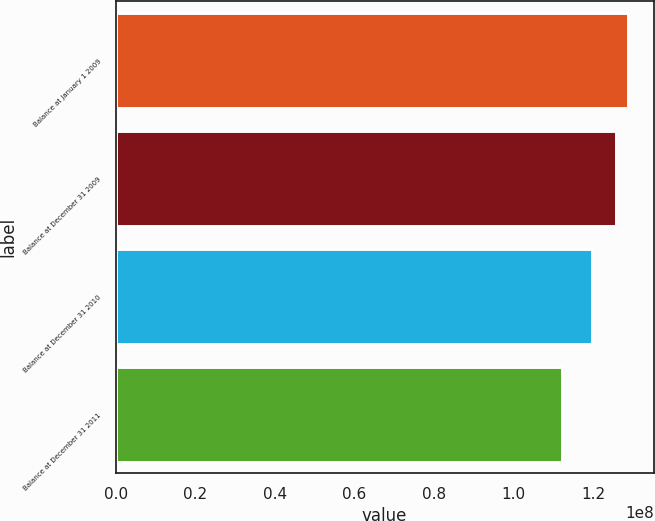Convert chart. <chart><loc_0><loc_0><loc_500><loc_500><bar_chart><fcel>Balance at January 1 2009<fcel>Balance at December 31 2009<fcel>Balance at December 31 2010<fcel>Balance at December 31 2011<nl><fcel>1.28812e+08<fcel>1.25812e+08<fcel>1.19812e+08<fcel>1.12312e+08<nl></chart> 